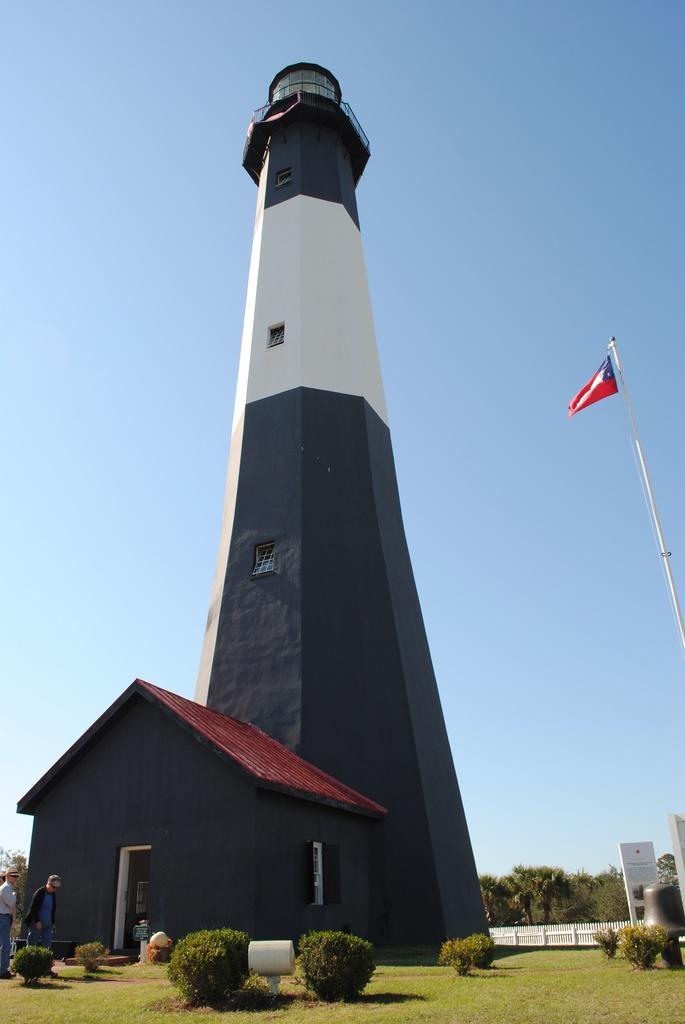Can you describe this image briefly? As we can see in the image there is a building, house, few people over here, grass, plants, trees and sky. 